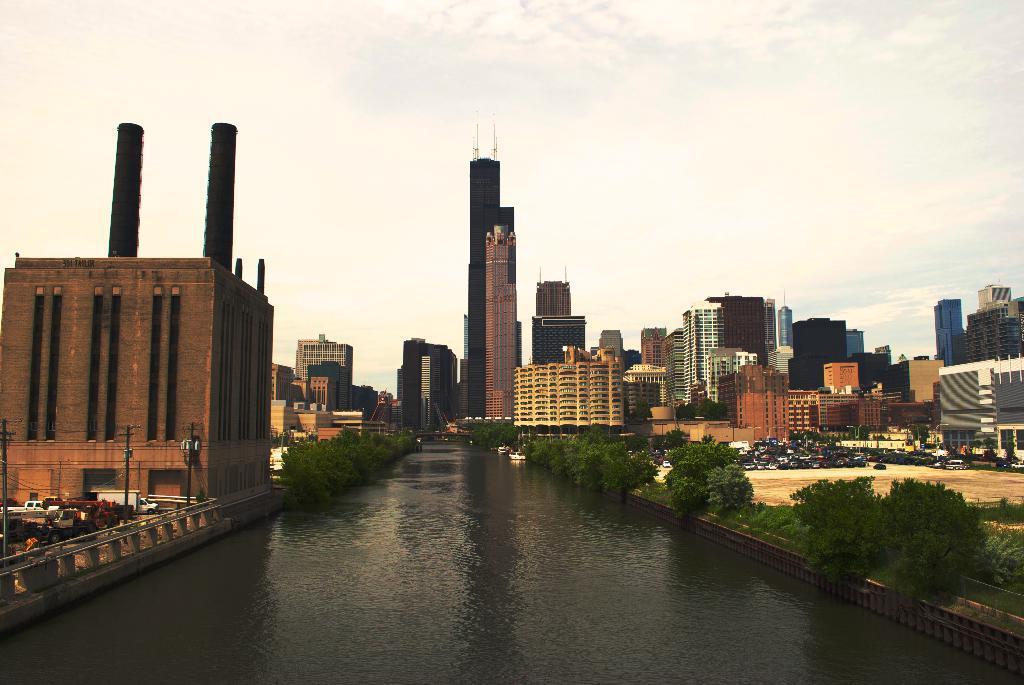In one or two sentences, can you explain what this image depicts? In this image there are buildings, vehicles, fencing and poles, trees in the left corner. There is water at the bottom. There are trees and buildings in the background. There are vehicles, buildings in the right corner. And there is a sky at the top. 